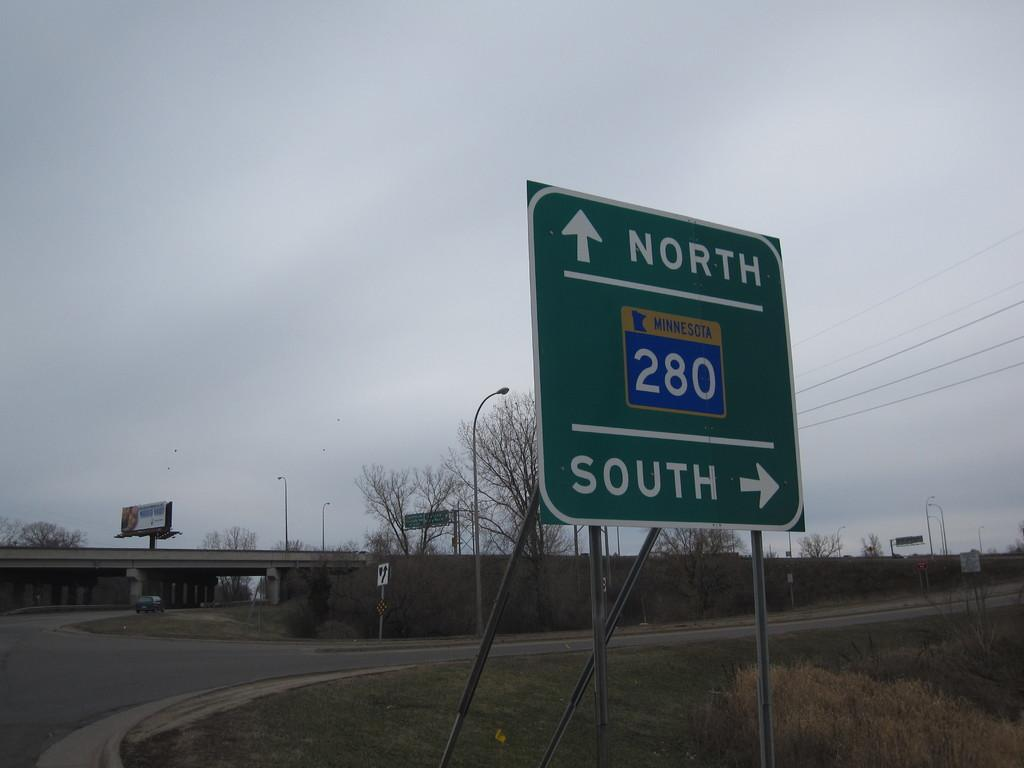<image>
Offer a succinct explanation of the picture presented. the word north that is on a sign 